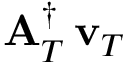<formula> <loc_0><loc_0><loc_500><loc_500>{ A } _ { T } ^ { \dagger } \, { { v } _ { T } }</formula> 